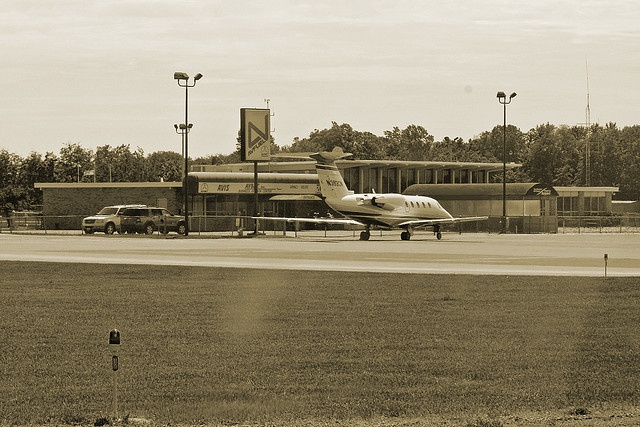Describe the objects in this image and their specific colors. I can see airplane in lightgray, tan, black, olive, and gray tones, truck in lightgray, black, and gray tones, car in lightgray, black, and gray tones, and car in lightgray, black, darkgreen, tan, and gray tones in this image. 